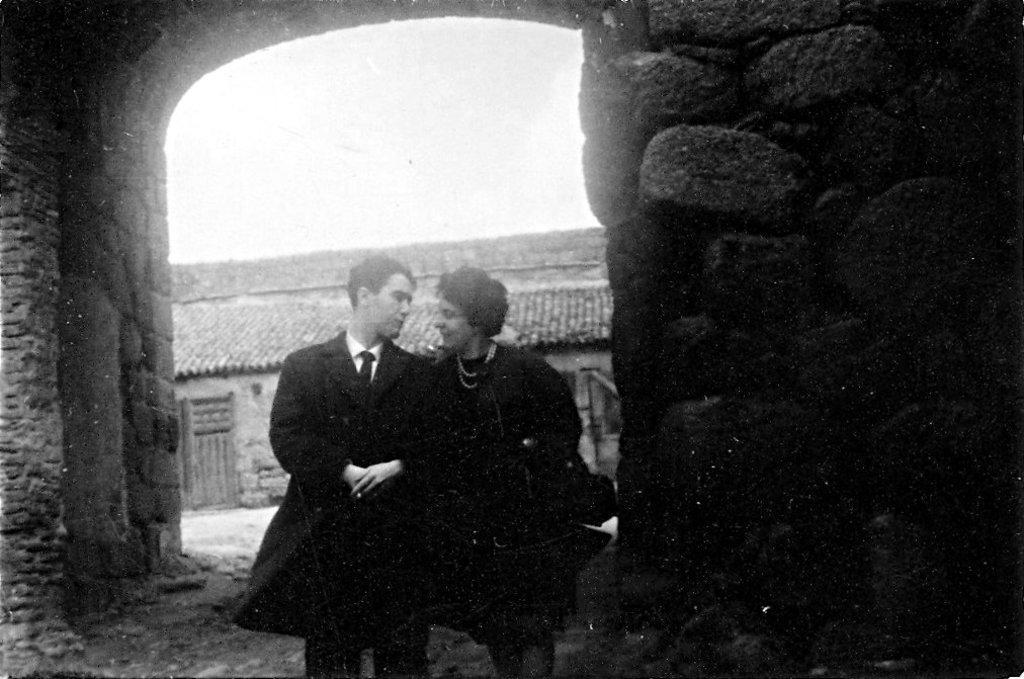Please provide a concise description of this image. This picture shows a man and a woman standing and we see a house on the back. 